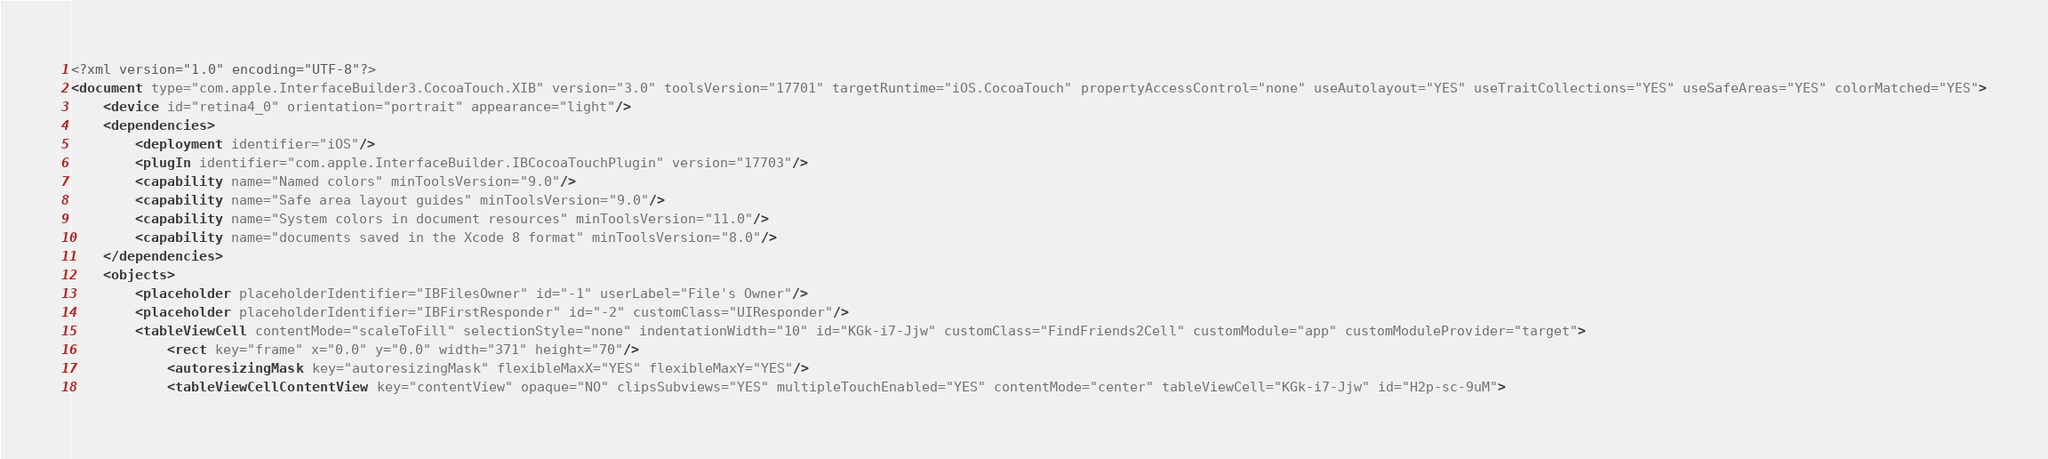<code> <loc_0><loc_0><loc_500><loc_500><_XML_><?xml version="1.0" encoding="UTF-8"?>
<document type="com.apple.InterfaceBuilder3.CocoaTouch.XIB" version="3.0" toolsVersion="17701" targetRuntime="iOS.CocoaTouch" propertyAccessControl="none" useAutolayout="YES" useTraitCollections="YES" useSafeAreas="YES" colorMatched="YES">
    <device id="retina4_0" orientation="portrait" appearance="light"/>
    <dependencies>
        <deployment identifier="iOS"/>
        <plugIn identifier="com.apple.InterfaceBuilder.IBCocoaTouchPlugin" version="17703"/>
        <capability name="Named colors" minToolsVersion="9.0"/>
        <capability name="Safe area layout guides" minToolsVersion="9.0"/>
        <capability name="System colors in document resources" minToolsVersion="11.0"/>
        <capability name="documents saved in the Xcode 8 format" minToolsVersion="8.0"/>
    </dependencies>
    <objects>
        <placeholder placeholderIdentifier="IBFilesOwner" id="-1" userLabel="File's Owner"/>
        <placeholder placeholderIdentifier="IBFirstResponder" id="-2" customClass="UIResponder"/>
        <tableViewCell contentMode="scaleToFill" selectionStyle="none" indentationWidth="10" id="KGk-i7-Jjw" customClass="FindFriends2Cell" customModule="app" customModuleProvider="target">
            <rect key="frame" x="0.0" y="0.0" width="371" height="70"/>
            <autoresizingMask key="autoresizingMask" flexibleMaxX="YES" flexibleMaxY="YES"/>
            <tableViewCellContentView key="contentView" opaque="NO" clipsSubviews="YES" multipleTouchEnabled="YES" contentMode="center" tableViewCell="KGk-i7-Jjw" id="H2p-sc-9uM"></code> 